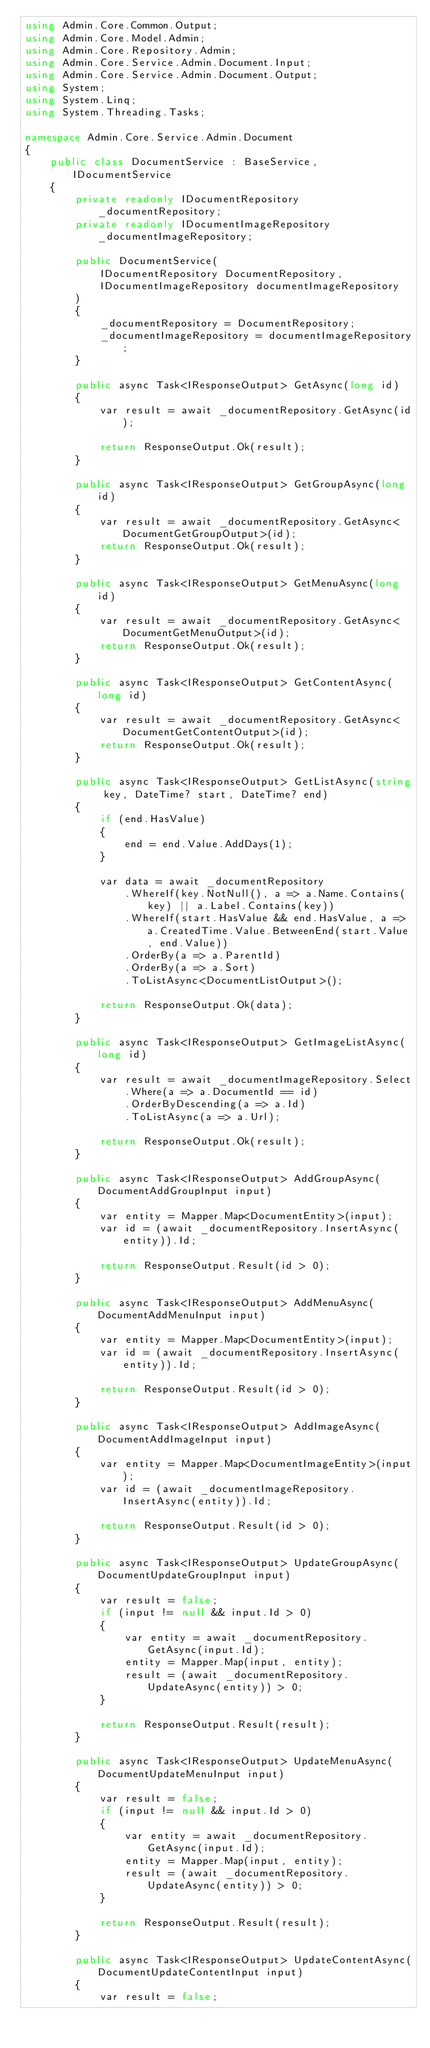Convert code to text. <code><loc_0><loc_0><loc_500><loc_500><_C#_>using Admin.Core.Common.Output;
using Admin.Core.Model.Admin;
using Admin.Core.Repository.Admin;
using Admin.Core.Service.Admin.Document.Input;
using Admin.Core.Service.Admin.Document.Output;
using System;
using System.Linq;
using System.Threading.Tasks;

namespace Admin.Core.Service.Admin.Document
{
    public class DocumentService : BaseService, IDocumentService
    {
        private readonly IDocumentRepository _documentRepository;
        private readonly IDocumentImageRepository _documentImageRepository;

        public DocumentService(
            IDocumentRepository DocumentRepository,
            IDocumentImageRepository documentImageRepository
        )
        {
            _documentRepository = DocumentRepository;
            _documentImageRepository = documentImageRepository;
        }

        public async Task<IResponseOutput> GetAsync(long id)
        {
            var result = await _documentRepository.GetAsync(id);

            return ResponseOutput.Ok(result);
        }

        public async Task<IResponseOutput> GetGroupAsync(long id)
        {
            var result = await _documentRepository.GetAsync<DocumentGetGroupOutput>(id);
            return ResponseOutput.Ok(result);
        }

        public async Task<IResponseOutput> GetMenuAsync(long id)
        {
            var result = await _documentRepository.GetAsync<DocumentGetMenuOutput>(id);
            return ResponseOutput.Ok(result);
        }

        public async Task<IResponseOutput> GetContentAsync(long id)
        {
            var result = await _documentRepository.GetAsync<DocumentGetContentOutput>(id);
            return ResponseOutput.Ok(result);
        }

        public async Task<IResponseOutput> GetListAsync(string key, DateTime? start, DateTime? end)
        {
            if (end.HasValue)
            {
                end = end.Value.AddDays(1);
            }

            var data = await _documentRepository
                .WhereIf(key.NotNull(), a => a.Name.Contains(key) || a.Label.Contains(key))
                .WhereIf(start.HasValue && end.HasValue, a => a.CreatedTime.Value.BetweenEnd(start.Value, end.Value))
                .OrderBy(a => a.ParentId)
                .OrderBy(a => a.Sort)
                .ToListAsync<DocumentListOutput>();

            return ResponseOutput.Ok(data);
        }

        public async Task<IResponseOutput> GetImageListAsync(long id)
        {
            var result = await _documentImageRepository.Select
                .Where(a => a.DocumentId == id)
                .OrderByDescending(a => a.Id)
                .ToListAsync(a => a.Url);

            return ResponseOutput.Ok(result);
        }

        public async Task<IResponseOutput> AddGroupAsync(DocumentAddGroupInput input)
        {
            var entity = Mapper.Map<DocumentEntity>(input);
            var id = (await _documentRepository.InsertAsync(entity)).Id;

            return ResponseOutput.Result(id > 0);
        }

        public async Task<IResponseOutput> AddMenuAsync(DocumentAddMenuInput input)
        {
            var entity = Mapper.Map<DocumentEntity>(input);
            var id = (await _documentRepository.InsertAsync(entity)).Id;

            return ResponseOutput.Result(id > 0);
        }

        public async Task<IResponseOutput> AddImageAsync(DocumentAddImageInput input)
        {
            var entity = Mapper.Map<DocumentImageEntity>(input);
            var id = (await _documentImageRepository.InsertAsync(entity)).Id;

            return ResponseOutput.Result(id > 0);
        }

        public async Task<IResponseOutput> UpdateGroupAsync(DocumentUpdateGroupInput input)
        {
            var result = false;
            if (input != null && input.Id > 0)
            {
                var entity = await _documentRepository.GetAsync(input.Id);
                entity = Mapper.Map(input, entity);
                result = (await _documentRepository.UpdateAsync(entity)) > 0;
            }

            return ResponseOutput.Result(result);
        }

        public async Task<IResponseOutput> UpdateMenuAsync(DocumentUpdateMenuInput input)
        {
            var result = false;
            if (input != null && input.Id > 0)
            {
                var entity = await _documentRepository.GetAsync(input.Id);
                entity = Mapper.Map(input, entity);
                result = (await _documentRepository.UpdateAsync(entity)) > 0;
            }

            return ResponseOutput.Result(result);
        }

        public async Task<IResponseOutput> UpdateContentAsync(DocumentUpdateContentInput input)
        {
            var result = false;</code> 